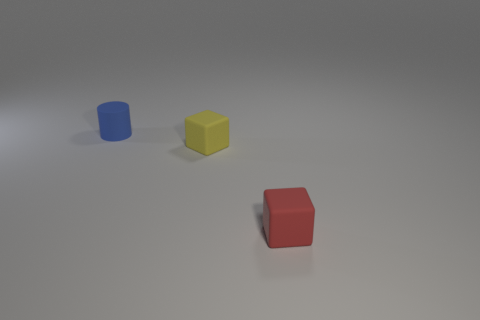Add 1 things. How many objects exist? 4 Subtract all cylinders. How many objects are left? 2 Add 1 yellow things. How many yellow things exist? 2 Subtract 0 brown cylinders. How many objects are left? 3 Subtract all purple spheres. Subtract all small red rubber things. How many objects are left? 2 Add 1 tiny yellow rubber cubes. How many tiny yellow rubber cubes are left? 2 